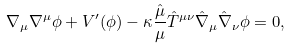Convert formula to latex. <formula><loc_0><loc_0><loc_500><loc_500>\nabla _ { \mu } \nabla ^ { \mu } \phi + V ^ { \prime } ( \phi ) - \kappa \frac { \hat { \mu } } { \mu } { \hat { T } } ^ { \mu \nu } { \hat { \nabla } } _ { \mu } { \hat { \nabla } } _ { \nu } \phi = 0 ,</formula> 